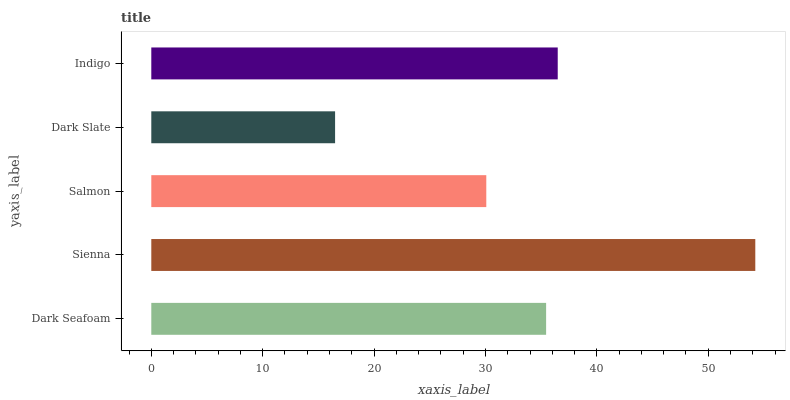Is Dark Slate the minimum?
Answer yes or no. Yes. Is Sienna the maximum?
Answer yes or no. Yes. Is Salmon the minimum?
Answer yes or no. No. Is Salmon the maximum?
Answer yes or no. No. Is Sienna greater than Salmon?
Answer yes or no. Yes. Is Salmon less than Sienna?
Answer yes or no. Yes. Is Salmon greater than Sienna?
Answer yes or no. No. Is Sienna less than Salmon?
Answer yes or no. No. Is Dark Seafoam the high median?
Answer yes or no. Yes. Is Dark Seafoam the low median?
Answer yes or no. Yes. Is Sienna the high median?
Answer yes or no. No. Is Indigo the low median?
Answer yes or no. No. 